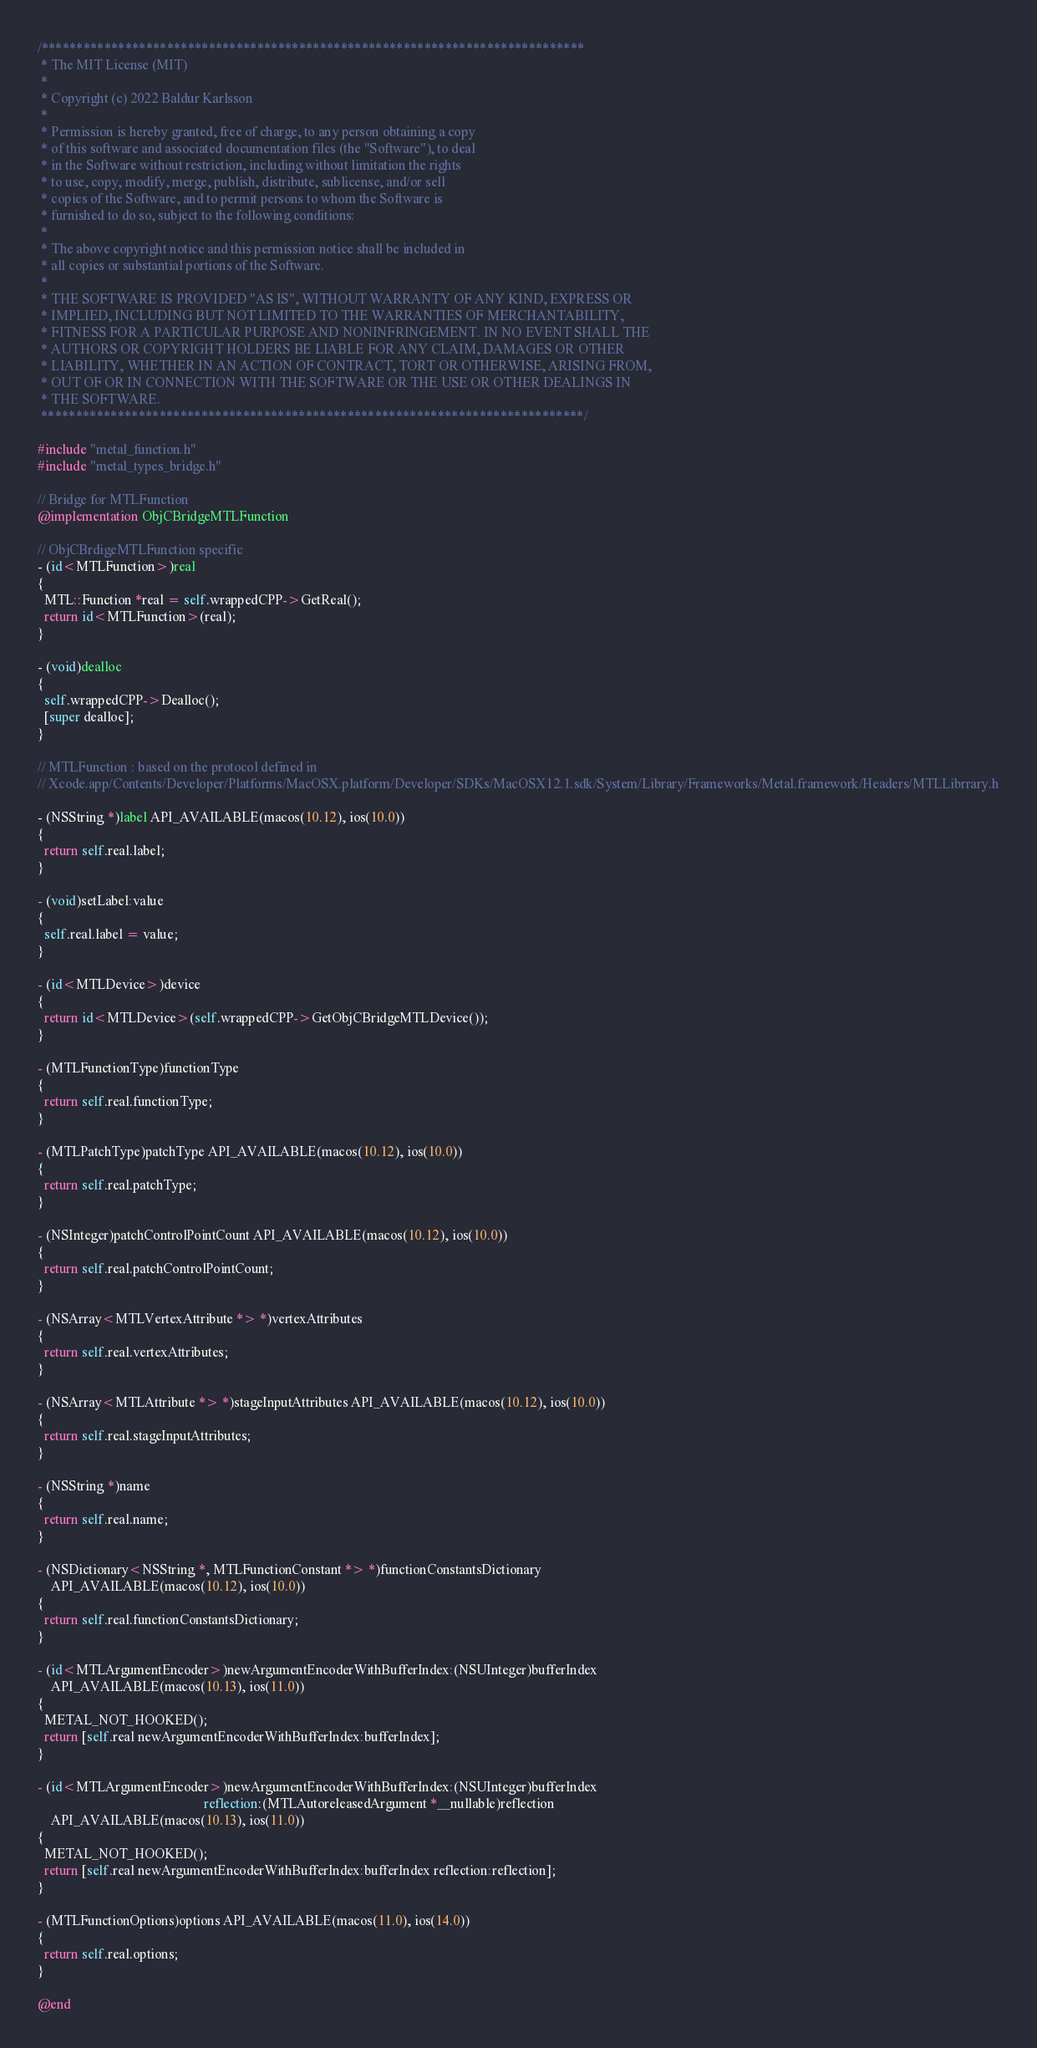Convert code to text. <code><loc_0><loc_0><loc_500><loc_500><_ObjectiveC_>/******************************************************************************
 * The MIT License (MIT)
 *
 * Copyright (c) 2022 Baldur Karlsson
 *
 * Permission is hereby granted, free of charge, to any person obtaining a copy
 * of this software and associated documentation files (the "Software"), to deal
 * in the Software without restriction, including without limitation the rights
 * to use, copy, modify, merge, publish, distribute, sublicense, and/or sell
 * copies of the Software, and to permit persons to whom the Software is
 * furnished to do so, subject to the following conditions:
 *
 * The above copyright notice and this permission notice shall be included in
 * all copies or substantial portions of the Software.
 *
 * THE SOFTWARE IS PROVIDED "AS IS", WITHOUT WARRANTY OF ANY KIND, EXPRESS OR
 * IMPLIED, INCLUDING BUT NOT LIMITED TO THE WARRANTIES OF MERCHANTABILITY,
 * FITNESS FOR A PARTICULAR PURPOSE AND NONINFRINGEMENT. IN NO EVENT SHALL THE
 * AUTHORS OR COPYRIGHT HOLDERS BE LIABLE FOR ANY CLAIM, DAMAGES OR OTHER
 * LIABILITY, WHETHER IN AN ACTION OF CONTRACT, TORT OR OTHERWISE, ARISING FROM,
 * OUT OF OR IN CONNECTION WITH THE SOFTWARE OR THE USE OR OTHER DEALINGS IN
 * THE SOFTWARE.
 ******************************************************************************/

#include "metal_function.h"
#include "metal_types_bridge.h"

// Bridge for MTLFunction
@implementation ObjCBridgeMTLFunction

// ObjCBrdigeMTLFunction specific
- (id<MTLFunction>)real
{
  MTL::Function *real = self.wrappedCPP->GetReal();
  return id<MTLFunction>(real);
}

- (void)dealloc
{
  self.wrappedCPP->Dealloc();
  [super dealloc];
}

// MTLFunction : based on the protocol defined in
// Xcode.app/Contents/Developer/Platforms/MacOSX.platform/Developer/SDKs/MacOSX12.1.sdk/System/Library/Frameworks/Metal.framework/Headers/MTLLibrrary.h

- (NSString *)label API_AVAILABLE(macos(10.12), ios(10.0))
{
  return self.real.label;
}

- (void)setLabel:value
{
  self.real.label = value;
}

- (id<MTLDevice>)device
{
  return id<MTLDevice>(self.wrappedCPP->GetObjCBridgeMTLDevice());
}

- (MTLFunctionType)functionType
{
  return self.real.functionType;
}

- (MTLPatchType)patchType API_AVAILABLE(macos(10.12), ios(10.0))
{
  return self.real.patchType;
}

- (NSInteger)patchControlPointCount API_AVAILABLE(macos(10.12), ios(10.0))
{
  return self.real.patchControlPointCount;
}

- (NSArray<MTLVertexAttribute *> *)vertexAttributes
{
  return self.real.vertexAttributes;
}

- (NSArray<MTLAttribute *> *)stageInputAttributes API_AVAILABLE(macos(10.12), ios(10.0))
{
  return self.real.stageInputAttributes;
}

- (NSString *)name
{
  return self.real.name;
}

- (NSDictionary<NSString *, MTLFunctionConstant *> *)functionConstantsDictionary
    API_AVAILABLE(macos(10.12), ios(10.0))
{
  return self.real.functionConstantsDictionary;
}

- (id<MTLArgumentEncoder>)newArgumentEncoderWithBufferIndex:(NSUInteger)bufferIndex
    API_AVAILABLE(macos(10.13), ios(11.0))
{
  METAL_NOT_HOOKED();
  return [self.real newArgumentEncoderWithBufferIndex:bufferIndex];
}

- (id<MTLArgumentEncoder>)newArgumentEncoderWithBufferIndex:(NSUInteger)bufferIndex
                                                 reflection:(MTLAutoreleasedArgument *__nullable)reflection
    API_AVAILABLE(macos(10.13), ios(11.0))
{
  METAL_NOT_HOOKED();
  return [self.real newArgumentEncoderWithBufferIndex:bufferIndex reflection:reflection];
}

- (MTLFunctionOptions)options API_AVAILABLE(macos(11.0), ios(14.0))
{
  return self.real.options;
}

@end
</code> 